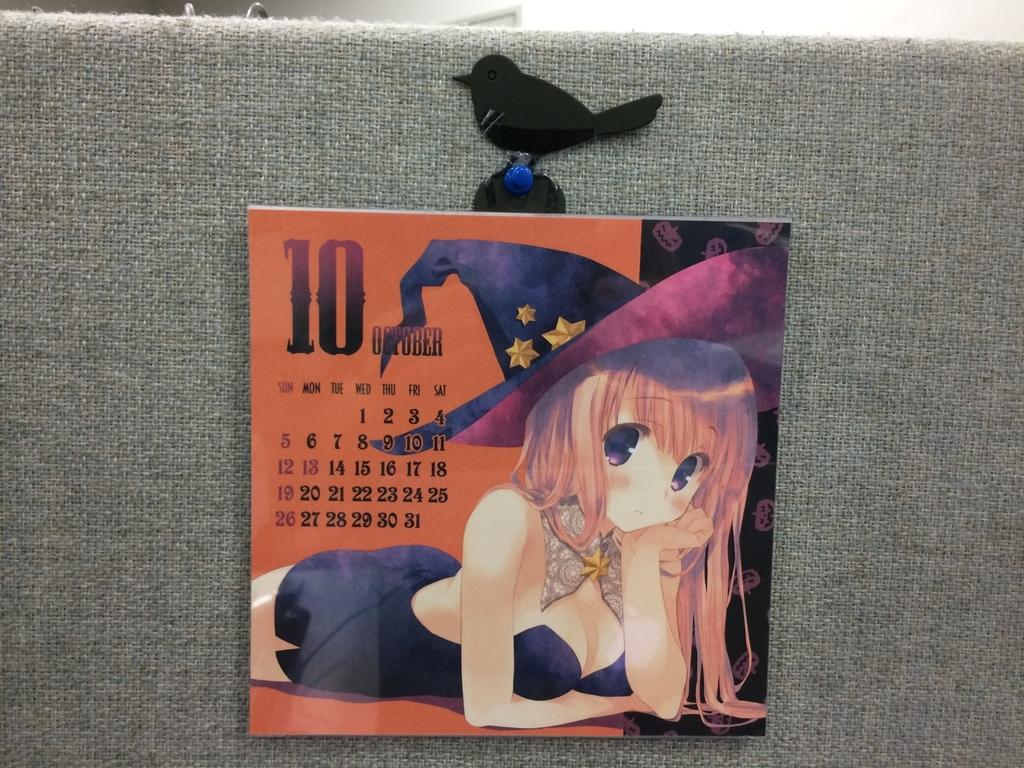What is the main subject of the picture? The main subject of the picture is a Barbie doll calendar. Can you describe the calendar in more detail? Unfortunately, the provided facts do not offer any additional details about the calendar. What is the body condition of the Barbie doll in the calendar? There is no information about the Barbie doll's body condition in the image, as the provided fact only mentions the presence of a Barbie doll calendar. 